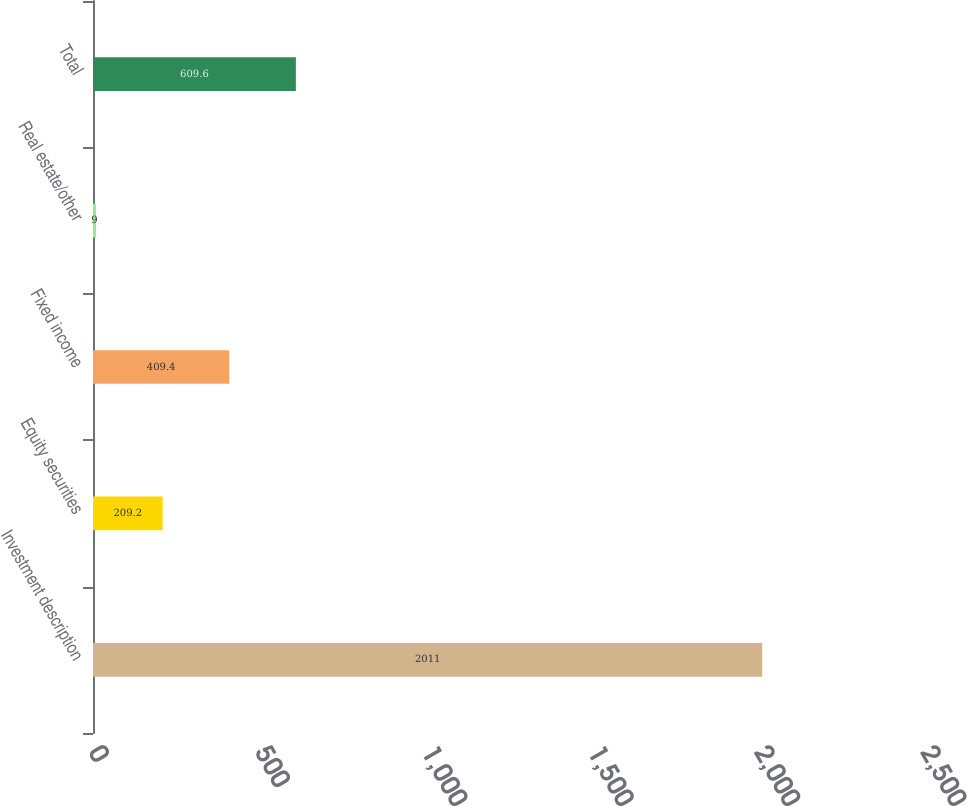Convert chart to OTSL. <chart><loc_0><loc_0><loc_500><loc_500><bar_chart><fcel>Investment description<fcel>Equity securities<fcel>Fixed income<fcel>Real estate/other<fcel>Total<nl><fcel>2011<fcel>209.2<fcel>409.4<fcel>9<fcel>609.6<nl></chart> 